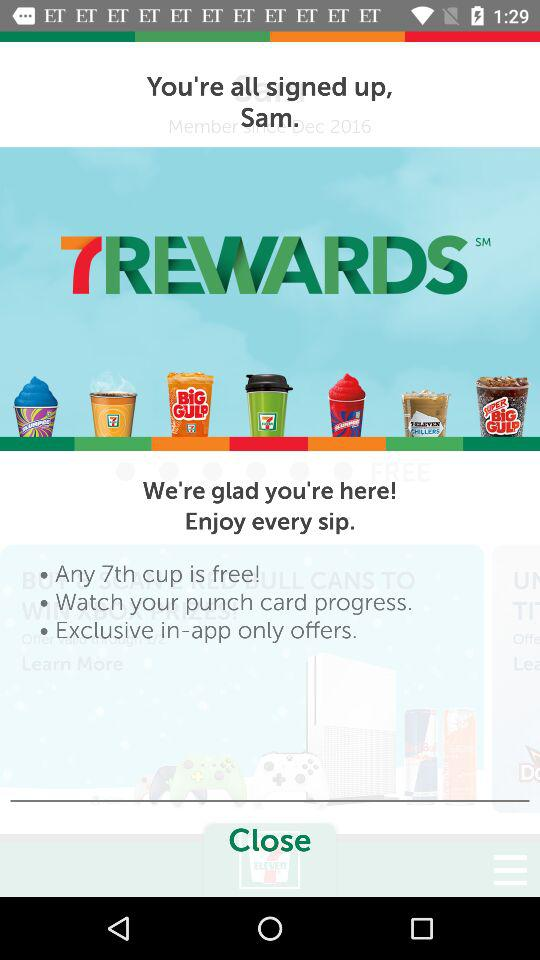How many different punch card rewards are there?
Answer the question using a single word or phrase. 7 